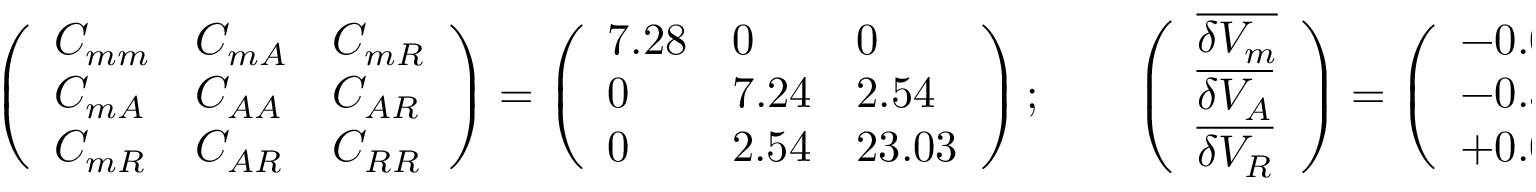Convert formula to latex. <formula><loc_0><loc_0><loc_500><loc_500>\left ( \begin{array} { l l l } { { C _ { m m } } } & { { C _ { m A } } } & { { C _ { m R } } } \\ { { C _ { m A } } } & { { C _ { A A } } } & { { C _ { A R } } } \\ { { C _ { m R } } } & { { C _ { A R } } } & { { C _ { R R } } } \end{array} \right ) = \left ( \begin{array} { l l l } { 7 . 2 8 } & { 0 } & { 0 } \\ { 0 } & { 7 . 2 4 } & { 2 . 5 4 } \\ { 0 } & { 2 . 5 4 } & { 2 3 . 0 3 } \end{array} \right ) ; \quad \left ( \begin{array} { l } { { \overline { { { \delta V _ { m } } } } } } \\ { { \overline { { { \delta V _ { A } } } } } } \\ { { \overline { { { \delta V _ { R } } } } } } \end{array} \right ) = \left ( \begin{array} { l } { - 0 . 0 7 } \\ { - 0 . 3 3 } \\ { + 0 . 0 1 } \end{array} \right ) .</formula> 